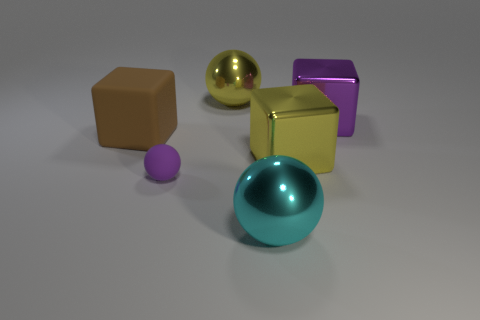Subtract all small spheres. How many spheres are left? 2 Add 4 big things. How many objects exist? 10 Subtract all brown blocks. How many blocks are left? 2 Subtract all purple cubes. Subtract all gray cylinders. How many cubes are left? 2 Subtract all cyan blocks. How many purple balls are left? 1 Subtract all cyan metallic cylinders. Subtract all yellow metal blocks. How many objects are left? 5 Add 5 spheres. How many spheres are left? 8 Add 1 gray matte objects. How many gray matte objects exist? 1 Subtract 0 green spheres. How many objects are left? 6 Subtract 1 blocks. How many blocks are left? 2 